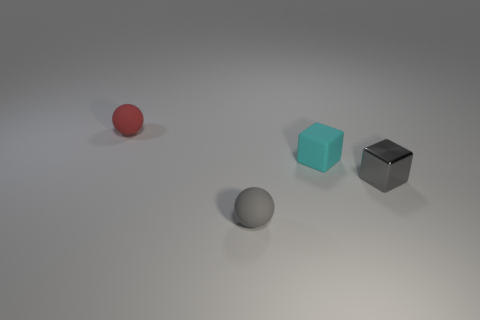The tiny object that is both right of the tiny gray rubber sphere and left of the tiny shiny cube has what shape?
Offer a very short reply. Cube. There is a metal cube; is it the same color as the small object that is left of the gray sphere?
Give a very brief answer. No. There is a sphere on the right side of the red thing; does it have the same size as the tiny red matte ball?
Offer a very short reply. Yes. What is the material of the small gray object that is the same shape as the tiny red matte thing?
Give a very brief answer. Rubber. Is the shape of the small gray metallic object the same as the red rubber object?
Your answer should be compact. No. There is a rubber sphere that is to the left of the small gray matte thing; how many tiny rubber objects are right of it?
Make the answer very short. 2. What is the shape of the tiny gray object that is made of the same material as the red object?
Provide a short and direct response. Sphere. What number of purple things are tiny cylinders or tiny rubber blocks?
Make the answer very short. 0. Is there a tiny red matte object behind the small sphere that is behind the small gray thing behind the tiny gray matte thing?
Ensure brevity in your answer.  No. Are there fewer tiny red objects than yellow balls?
Provide a succinct answer. No. 